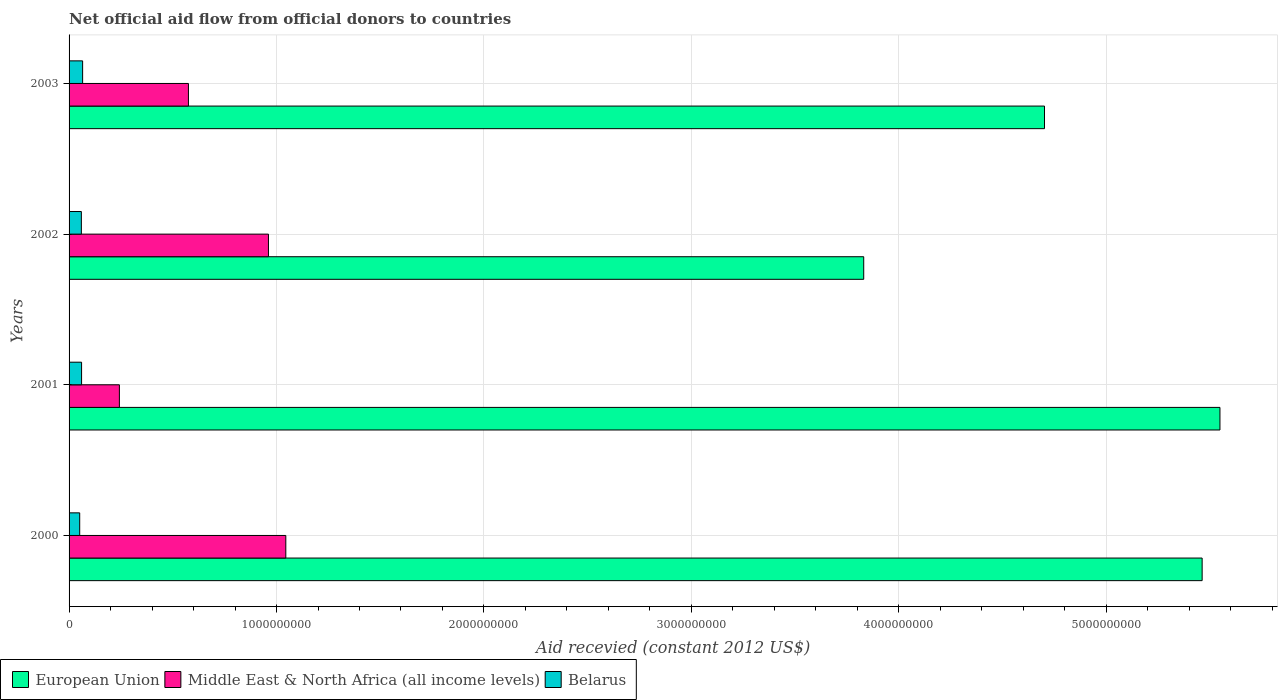Are the number of bars per tick equal to the number of legend labels?
Offer a very short reply. Yes. How many bars are there on the 3rd tick from the top?
Your answer should be very brief. 3. How many bars are there on the 3rd tick from the bottom?
Your response must be concise. 3. In how many cases, is the number of bars for a given year not equal to the number of legend labels?
Keep it short and to the point. 0. What is the total aid received in European Union in 2003?
Your answer should be very brief. 4.70e+09. Across all years, what is the maximum total aid received in Middle East & North Africa (all income levels)?
Provide a short and direct response. 1.04e+09. Across all years, what is the minimum total aid received in European Union?
Your answer should be very brief. 3.83e+09. What is the total total aid received in Middle East & North Africa (all income levels) in the graph?
Offer a very short reply. 2.82e+09. What is the difference between the total aid received in Middle East & North Africa (all income levels) in 2001 and that in 2002?
Offer a terse response. -7.19e+08. What is the difference between the total aid received in Middle East & North Africa (all income levels) in 2000 and the total aid received in Belarus in 2002?
Your answer should be compact. 9.86e+08. What is the average total aid received in European Union per year?
Keep it short and to the point. 4.89e+09. In the year 2001, what is the difference between the total aid received in European Union and total aid received in Middle East & North Africa (all income levels)?
Give a very brief answer. 5.31e+09. What is the ratio of the total aid received in European Union in 2001 to that in 2002?
Your answer should be compact. 1.45. Is the total aid received in Belarus in 2001 less than that in 2002?
Make the answer very short. No. What is the difference between the highest and the second highest total aid received in Middle East & North Africa (all income levels)?
Make the answer very short. 8.36e+07. What is the difference between the highest and the lowest total aid received in Belarus?
Offer a terse response. 1.41e+07. What does the 1st bar from the top in 2001 represents?
Your answer should be compact. Belarus. What does the 3rd bar from the bottom in 2002 represents?
Make the answer very short. Belarus. Is it the case that in every year, the sum of the total aid received in Middle East & North Africa (all income levels) and total aid received in Belarus is greater than the total aid received in European Union?
Provide a succinct answer. No. How many bars are there?
Keep it short and to the point. 12. Are all the bars in the graph horizontal?
Ensure brevity in your answer.  Yes. How many years are there in the graph?
Ensure brevity in your answer.  4. Are the values on the major ticks of X-axis written in scientific E-notation?
Offer a terse response. No. Does the graph contain any zero values?
Your response must be concise. No. Does the graph contain grids?
Your answer should be very brief. Yes. Where does the legend appear in the graph?
Offer a terse response. Bottom left. How many legend labels are there?
Keep it short and to the point. 3. How are the legend labels stacked?
Your response must be concise. Horizontal. What is the title of the graph?
Give a very brief answer. Net official aid flow from official donors to countries. Does "Faeroe Islands" appear as one of the legend labels in the graph?
Give a very brief answer. No. What is the label or title of the X-axis?
Your answer should be very brief. Aid recevied (constant 2012 US$). What is the label or title of the Y-axis?
Provide a short and direct response. Years. What is the Aid recevied (constant 2012 US$) of European Union in 2000?
Make the answer very short. 5.46e+09. What is the Aid recevied (constant 2012 US$) of Middle East & North Africa (all income levels) in 2000?
Your answer should be very brief. 1.04e+09. What is the Aid recevied (constant 2012 US$) in Belarus in 2000?
Your answer should be compact. 5.12e+07. What is the Aid recevied (constant 2012 US$) in European Union in 2001?
Your response must be concise. 5.55e+09. What is the Aid recevied (constant 2012 US$) in Middle East & North Africa (all income levels) in 2001?
Offer a very short reply. 2.43e+08. What is the Aid recevied (constant 2012 US$) in Belarus in 2001?
Keep it short and to the point. 6.03e+07. What is the Aid recevied (constant 2012 US$) in European Union in 2002?
Your answer should be compact. 3.83e+09. What is the Aid recevied (constant 2012 US$) in Middle East & North Africa (all income levels) in 2002?
Your response must be concise. 9.61e+08. What is the Aid recevied (constant 2012 US$) in Belarus in 2002?
Offer a terse response. 5.93e+07. What is the Aid recevied (constant 2012 US$) in European Union in 2003?
Your response must be concise. 4.70e+09. What is the Aid recevied (constant 2012 US$) of Middle East & North Africa (all income levels) in 2003?
Offer a very short reply. 5.75e+08. What is the Aid recevied (constant 2012 US$) in Belarus in 2003?
Your answer should be compact. 6.53e+07. Across all years, what is the maximum Aid recevied (constant 2012 US$) in European Union?
Provide a succinct answer. 5.55e+09. Across all years, what is the maximum Aid recevied (constant 2012 US$) of Middle East & North Africa (all income levels)?
Make the answer very short. 1.04e+09. Across all years, what is the maximum Aid recevied (constant 2012 US$) of Belarus?
Give a very brief answer. 6.53e+07. Across all years, what is the minimum Aid recevied (constant 2012 US$) of European Union?
Provide a succinct answer. 3.83e+09. Across all years, what is the minimum Aid recevied (constant 2012 US$) in Middle East & North Africa (all income levels)?
Ensure brevity in your answer.  2.43e+08. Across all years, what is the minimum Aid recevied (constant 2012 US$) of Belarus?
Your answer should be very brief. 5.12e+07. What is the total Aid recevied (constant 2012 US$) of European Union in the graph?
Keep it short and to the point. 1.95e+1. What is the total Aid recevied (constant 2012 US$) in Middle East & North Africa (all income levels) in the graph?
Keep it short and to the point. 2.82e+09. What is the total Aid recevied (constant 2012 US$) in Belarus in the graph?
Give a very brief answer. 2.36e+08. What is the difference between the Aid recevied (constant 2012 US$) of European Union in 2000 and that in 2001?
Your answer should be very brief. -8.58e+07. What is the difference between the Aid recevied (constant 2012 US$) in Middle East & North Africa (all income levels) in 2000 and that in 2001?
Your answer should be very brief. 8.02e+08. What is the difference between the Aid recevied (constant 2012 US$) of Belarus in 2000 and that in 2001?
Your response must be concise. -9.04e+06. What is the difference between the Aid recevied (constant 2012 US$) of European Union in 2000 and that in 2002?
Provide a short and direct response. 1.63e+09. What is the difference between the Aid recevied (constant 2012 US$) in Middle East & North Africa (all income levels) in 2000 and that in 2002?
Ensure brevity in your answer.  8.36e+07. What is the difference between the Aid recevied (constant 2012 US$) of Belarus in 2000 and that in 2002?
Your answer should be compact. -8.02e+06. What is the difference between the Aid recevied (constant 2012 US$) in European Union in 2000 and that in 2003?
Your answer should be very brief. 7.60e+08. What is the difference between the Aid recevied (constant 2012 US$) in Middle East & North Africa (all income levels) in 2000 and that in 2003?
Offer a very short reply. 4.69e+08. What is the difference between the Aid recevied (constant 2012 US$) of Belarus in 2000 and that in 2003?
Provide a short and direct response. -1.41e+07. What is the difference between the Aid recevied (constant 2012 US$) in European Union in 2001 and that in 2002?
Your answer should be compact. 1.72e+09. What is the difference between the Aid recevied (constant 2012 US$) of Middle East & North Africa (all income levels) in 2001 and that in 2002?
Give a very brief answer. -7.19e+08. What is the difference between the Aid recevied (constant 2012 US$) in Belarus in 2001 and that in 2002?
Offer a terse response. 1.02e+06. What is the difference between the Aid recevied (constant 2012 US$) of European Union in 2001 and that in 2003?
Offer a terse response. 8.46e+08. What is the difference between the Aid recevied (constant 2012 US$) in Middle East & North Africa (all income levels) in 2001 and that in 2003?
Ensure brevity in your answer.  -3.33e+08. What is the difference between the Aid recevied (constant 2012 US$) in Belarus in 2001 and that in 2003?
Keep it short and to the point. -5.04e+06. What is the difference between the Aid recevied (constant 2012 US$) of European Union in 2002 and that in 2003?
Your response must be concise. -8.71e+08. What is the difference between the Aid recevied (constant 2012 US$) in Middle East & North Africa (all income levels) in 2002 and that in 2003?
Ensure brevity in your answer.  3.86e+08. What is the difference between the Aid recevied (constant 2012 US$) of Belarus in 2002 and that in 2003?
Offer a terse response. -6.06e+06. What is the difference between the Aid recevied (constant 2012 US$) in European Union in 2000 and the Aid recevied (constant 2012 US$) in Middle East & North Africa (all income levels) in 2001?
Ensure brevity in your answer.  5.22e+09. What is the difference between the Aid recevied (constant 2012 US$) of European Union in 2000 and the Aid recevied (constant 2012 US$) of Belarus in 2001?
Offer a terse response. 5.40e+09. What is the difference between the Aid recevied (constant 2012 US$) in Middle East & North Africa (all income levels) in 2000 and the Aid recevied (constant 2012 US$) in Belarus in 2001?
Your answer should be compact. 9.85e+08. What is the difference between the Aid recevied (constant 2012 US$) of European Union in 2000 and the Aid recevied (constant 2012 US$) of Middle East & North Africa (all income levels) in 2002?
Give a very brief answer. 4.50e+09. What is the difference between the Aid recevied (constant 2012 US$) in European Union in 2000 and the Aid recevied (constant 2012 US$) in Belarus in 2002?
Offer a very short reply. 5.40e+09. What is the difference between the Aid recevied (constant 2012 US$) in Middle East & North Africa (all income levels) in 2000 and the Aid recevied (constant 2012 US$) in Belarus in 2002?
Offer a terse response. 9.86e+08. What is the difference between the Aid recevied (constant 2012 US$) of European Union in 2000 and the Aid recevied (constant 2012 US$) of Middle East & North Africa (all income levels) in 2003?
Offer a terse response. 4.89e+09. What is the difference between the Aid recevied (constant 2012 US$) of European Union in 2000 and the Aid recevied (constant 2012 US$) of Belarus in 2003?
Provide a short and direct response. 5.40e+09. What is the difference between the Aid recevied (constant 2012 US$) in Middle East & North Africa (all income levels) in 2000 and the Aid recevied (constant 2012 US$) in Belarus in 2003?
Provide a succinct answer. 9.80e+08. What is the difference between the Aid recevied (constant 2012 US$) in European Union in 2001 and the Aid recevied (constant 2012 US$) in Middle East & North Africa (all income levels) in 2002?
Provide a succinct answer. 4.59e+09. What is the difference between the Aid recevied (constant 2012 US$) of European Union in 2001 and the Aid recevied (constant 2012 US$) of Belarus in 2002?
Your answer should be compact. 5.49e+09. What is the difference between the Aid recevied (constant 2012 US$) in Middle East & North Africa (all income levels) in 2001 and the Aid recevied (constant 2012 US$) in Belarus in 2002?
Make the answer very short. 1.83e+08. What is the difference between the Aid recevied (constant 2012 US$) of European Union in 2001 and the Aid recevied (constant 2012 US$) of Middle East & North Africa (all income levels) in 2003?
Your answer should be compact. 4.97e+09. What is the difference between the Aid recevied (constant 2012 US$) of European Union in 2001 and the Aid recevied (constant 2012 US$) of Belarus in 2003?
Offer a terse response. 5.48e+09. What is the difference between the Aid recevied (constant 2012 US$) in Middle East & North Africa (all income levels) in 2001 and the Aid recevied (constant 2012 US$) in Belarus in 2003?
Make the answer very short. 1.77e+08. What is the difference between the Aid recevied (constant 2012 US$) of European Union in 2002 and the Aid recevied (constant 2012 US$) of Middle East & North Africa (all income levels) in 2003?
Provide a succinct answer. 3.26e+09. What is the difference between the Aid recevied (constant 2012 US$) in European Union in 2002 and the Aid recevied (constant 2012 US$) in Belarus in 2003?
Ensure brevity in your answer.  3.77e+09. What is the difference between the Aid recevied (constant 2012 US$) in Middle East & North Africa (all income levels) in 2002 and the Aid recevied (constant 2012 US$) in Belarus in 2003?
Your response must be concise. 8.96e+08. What is the average Aid recevied (constant 2012 US$) of European Union per year?
Ensure brevity in your answer.  4.89e+09. What is the average Aid recevied (constant 2012 US$) of Middle East & North Africa (all income levels) per year?
Provide a succinct answer. 7.06e+08. What is the average Aid recevied (constant 2012 US$) of Belarus per year?
Make the answer very short. 5.90e+07. In the year 2000, what is the difference between the Aid recevied (constant 2012 US$) in European Union and Aid recevied (constant 2012 US$) in Middle East & North Africa (all income levels)?
Offer a very short reply. 4.42e+09. In the year 2000, what is the difference between the Aid recevied (constant 2012 US$) in European Union and Aid recevied (constant 2012 US$) in Belarus?
Give a very brief answer. 5.41e+09. In the year 2000, what is the difference between the Aid recevied (constant 2012 US$) in Middle East & North Africa (all income levels) and Aid recevied (constant 2012 US$) in Belarus?
Provide a succinct answer. 9.94e+08. In the year 2001, what is the difference between the Aid recevied (constant 2012 US$) in European Union and Aid recevied (constant 2012 US$) in Middle East & North Africa (all income levels)?
Offer a terse response. 5.31e+09. In the year 2001, what is the difference between the Aid recevied (constant 2012 US$) in European Union and Aid recevied (constant 2012 US$) in Belarus?
Give a very brief answer. 5.49e+09. In the year 2001, what is the difference between the Aid recevied (constant 2012 US$) in Middle East & North Africa (all income levels) and Aid recevied (constant 2012 US$) in Belarus?
Your answer should be very brief. 1.82e+08. In the year 2002, what is the difference between the Aid recevied (constant 2012 US$) of European Union and Aid recevied (constant 2012 US$) of Middle East & North Africa (all income levels)?
Offer a terse response. 2.87e+09. In the year 2002, what is the difference between the Aid recevied (constant 2012 US$) in European Union and Aid recevied (constant 2012 US$) in Belarus?
Your answer should be compact. 3.77e+09. In the year 2002, what is the difference between the Aid recevied (constant 2012 US$) of Middle East & North Africa (all income levels) and Aid recevied (constant 2012 US$) of Belarus?
Your response must be concise. 9.02e+08. In the year 2003, what is the difference between the Aid recevied (constant 2012 US$) of European Union and Aid recevied (constant 2012 US$) of Middle East & North Africa (all income levels)?
Your response must be concise. 4.13e+09. In the year 2003, what is the difference between the Aid recevied (constant 2012 US$) of European Union and Aid recevied (constant 2012 US$) of Belarus?
Offer a terse response. 4.64e+09. In the year 2003, what is the difference between the Aid recevied (constant 2012 US$) of Middle East & North Africa (all income levels) and Aid recevied (constant 2012 US$) of Belarus?
Give a very brief answer. 5.10e+08. What is the ratio of the Aid recevied (constant 2012 US$) in European Union in 2000 to that in 2001?
Your response must be concise. 0.98. What is the ratio of the Aid recevied (constant 2012 US$) in Middle East & North Africa (all income levels) in 2000 to that in 2001?
Offer a terse response. 4.31. What is the ratio of the Aid recevied (constant 2012 US$) in Belarus in 2000 to that in 2001?
Your response must be concise. 0.85. What is the ratio of the Aid recevied (constant 2012 US$) in European Union in 2000 to that in 2002?
Your response must be concise. 1.43. What is the ratio of the Aid recevied (constant 2012 US$) of Middle East & North Africa (all income levels) in 2000 to that in 2002?
Make the answer very short. 1.09. What is the ratio of the Aid recevied (constant 2012 US$) in Belarus in 2000 to that in 2002?
Ensure brevity in your answer.  0.86. What is the ratio of the Aid recevied (constant 2012 US$) of European Union in 2000 to that in 2003?
Provide a short and direct response. 1.16. What is the ratio of the Aid recevied (constant 2012 US$) of Middle East & North Africa (all income levels) in 2000 to that in 2003?
Offer a terse response. 1.82. What is the ratio of the Aid recevied (constant 2012 US$) of Belarus in 2000 to that in 2003?
Make the answer very short. 0.78. What is the ratio of the Aid recevied (constant 2012 US$) in European Union in 2001 to that in 2002?
Give a very brief answer. 1.45. What is the ratio of the Aid recevied (constant 2012 US$) in Middle East & North Africa (all income levels) in 2001 to that in 2002?
Make the answer very short. 0.25. What is the ratio of the Aid recevied (constant 2012 US$) of Belarus in 2001 to that in 2002?
Make the answer very short. 1.02. What is the ratio of the Aid recevied (constant 2012 US$) in European Union in 2001 to that in 2003?
Provide a succinct answer. 1.18. What is the ratio of the Aid recevied (constant 2012 US$) of Middle East & North Africa (all income levels) in 2001 to that in 2003?
Make the answer very short. 0.42. What is the ratio of the Aid recevied (constant 2012 US$) of Belarus in 2001 to that in 2003?
Offer a terse response. 0.92. What is the ratio of the Aid recevied (constant 2012 US$) of European Union in 2002 to that in 2003?
Keep it short and to the point. 0.81. What is the ratio of the Aid recevied (constant 2012 US$) in Middle East & North Africa (all income levels) in 2002 to that in 2003?
Offer a terse response. 1.67. What is the ratio of the Aid recevied (constant 2012 US$) in Belarus in 2002 to that in 2003?
Make the answer very short. 0.91. What is the difference between the highest and the second highest Aid recevied (constant 2012 US$) of European Union?
Your answer should be very brief. 8.58e+07. What is the difference between the highest and the second highest Aid recevied (constant 2012 US$) of Middle East & North Africa (all income levels)?
Offer a very short reply. 8.36e+07. What is the difference between the highest and the second highest Aid recevied (constant 2012 US$) in Belarus?
Give a very brief answer. 5.04e+06. What is the difference between the highest and the lowest Aid recevied (constant 2012 US$) in European Union?
Provide a short and direct response. 1.72e+09. What is the difference between the highest and the lowest Aid recevied (constant 2012 US$) in Middle East & North Africa (all income levels)?
Your response must be concise. 8.02e+08. What is the difference between the highest and the lowest Aid recevied (constant 2012 US$) in Belarus?
Keep it short and to the point. 1.41e+07. 